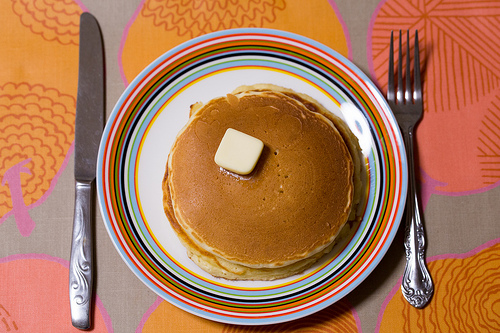<image>
Is there a butter on the fork? No. The butter is not positioned on the fork. They may be near each other, but the butter is not supported by or resting on top of the fork. 